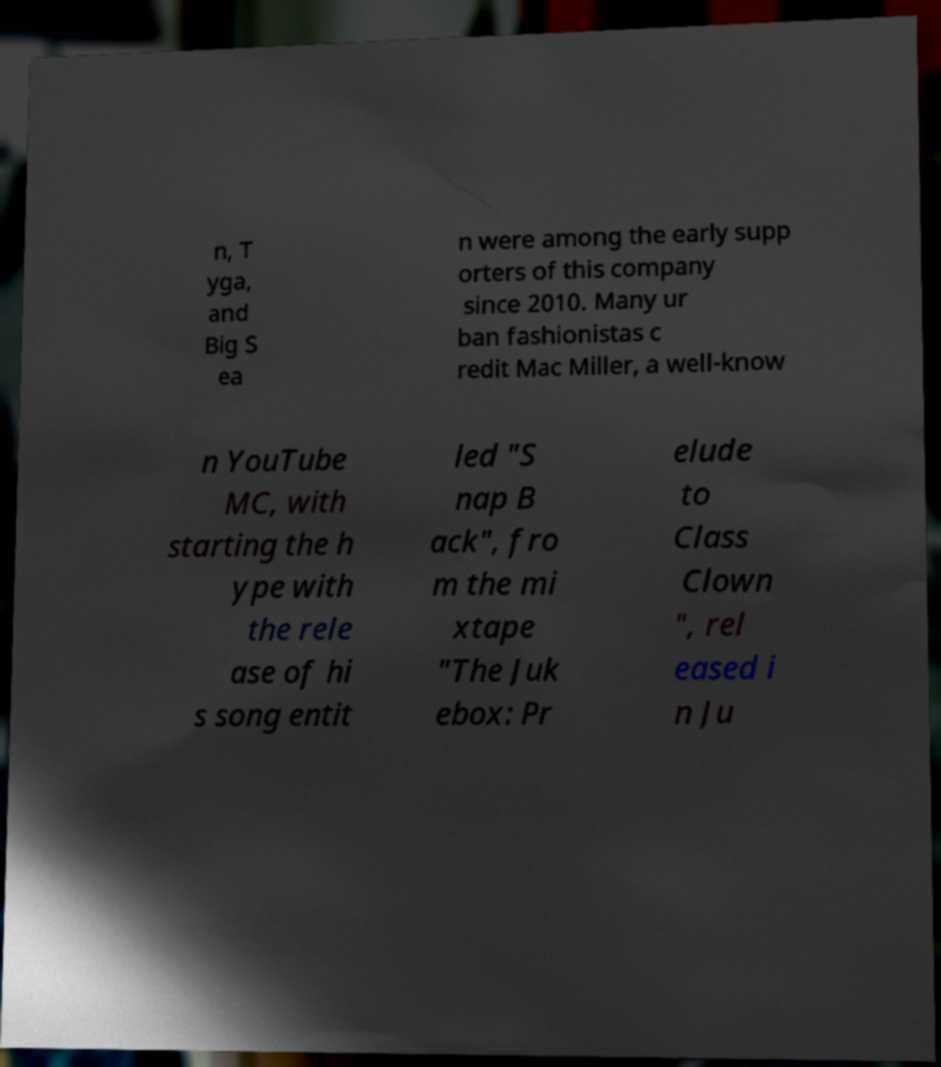There's text embedded in this image that I need extracted. Can you transcribe it verbatim? n, T yga, and Big S ea n were among the early supp orters of this company since 2010. Many ur ban fashionistas c redit Mac Miller, a well-know n YouTube MC, with starting the h ype with the rele ase of hi s song entit led "S nap B ack", fro m the mi xtape "The Juk ebox: Pr elude to Class Clown ", rel eased i n Ju 